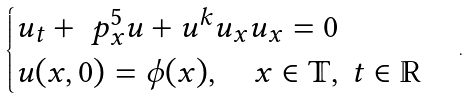<formula> <loc_0><loc_0><loc_500><loc_500>\begin{cases} u _ { t } + \ p _ { x } ^ { 5 } u + u ^ { k } u _ { x } u _ { x } = 0 \\ u ( x , 0 ) = \phi ( x ) , \quad x \in \mathbb { T } , \ t \in \mathbb { R } \end{cases} .</formula> 